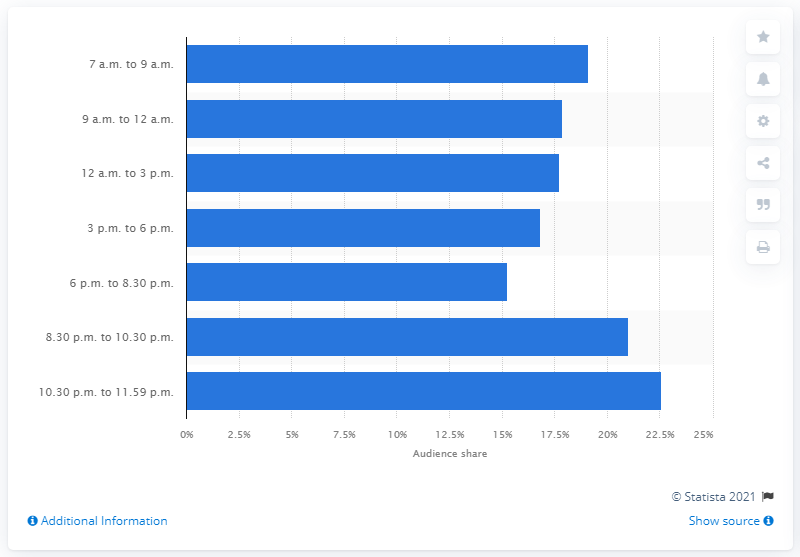Indicate a few pertinent items in this graphic. In March 2021, the audience share of Rai 1 between 6 p.m. and 8:30 p.m. was X. In March 2021, the audience share between 3 p.m. and 6 p.m. was 15.24%. 